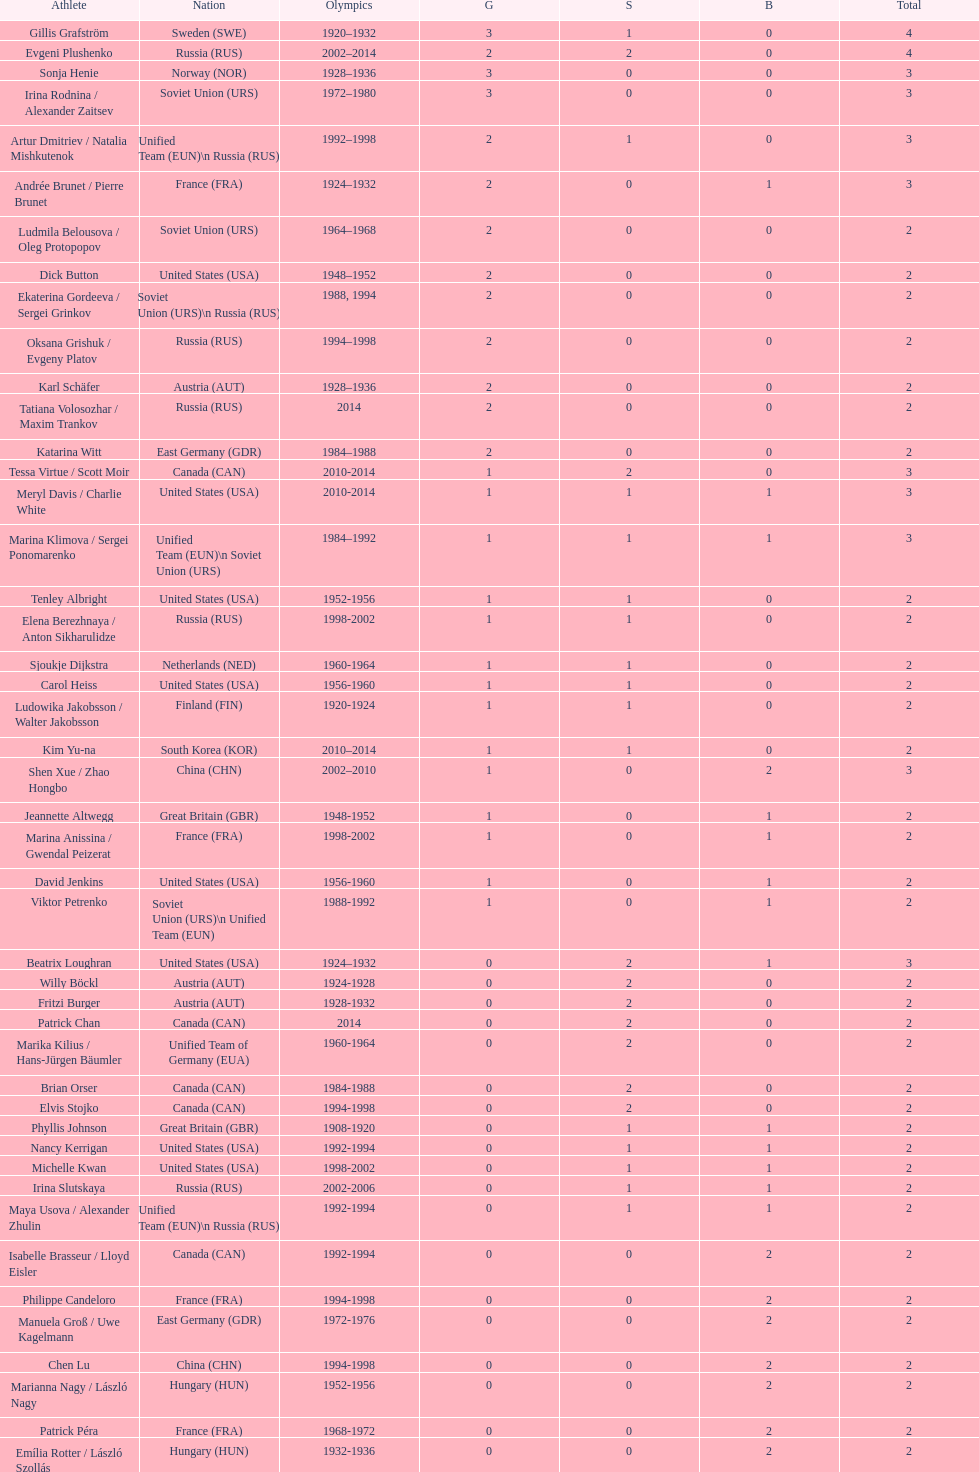How many more silver medals did gillis grafström have compared to sonja henie? 1. 